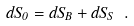<formula> <loc_0><loc_0><loc_500><loc_500>d S _ { 0 } = d S _ { B } + d S _ { S } \ .</formula> 